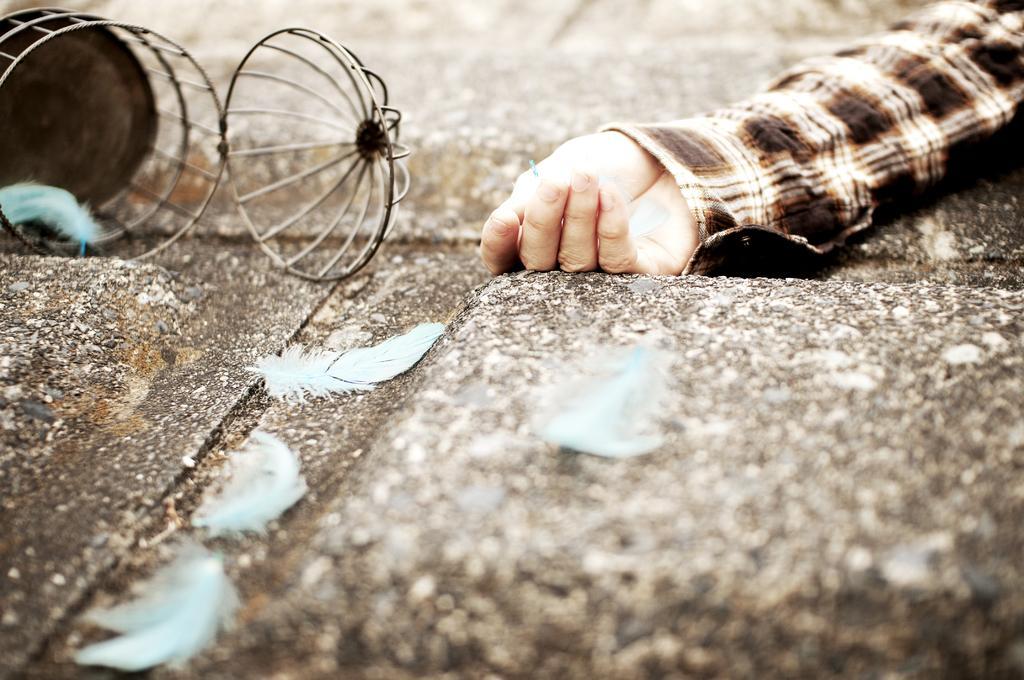How would you summarize this image in a sentence or two? In the picture we can see a path with a person's hand near it, we can see a fallen bird cage on the floor, which is opened and from it we can see some feathers which are blue in color. 